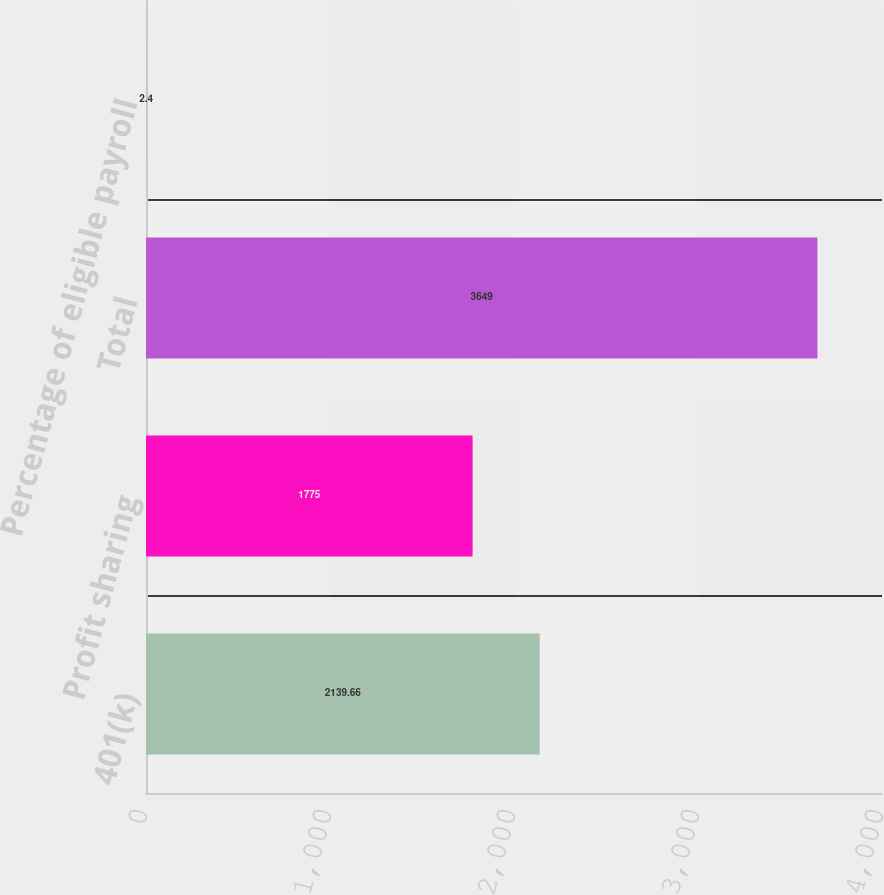Convert chart to OTSL. <chart><loc_0><loc_0><loc_500><loc_500><bar_chart><fcel>401(k)<fcel>Profit sharing<fcel>Total<fcel>Percentage of eligible payroll<nl><fcel>2139.66<fcel>1775<fcel>3649<fcel>2.4<nl></chart> 